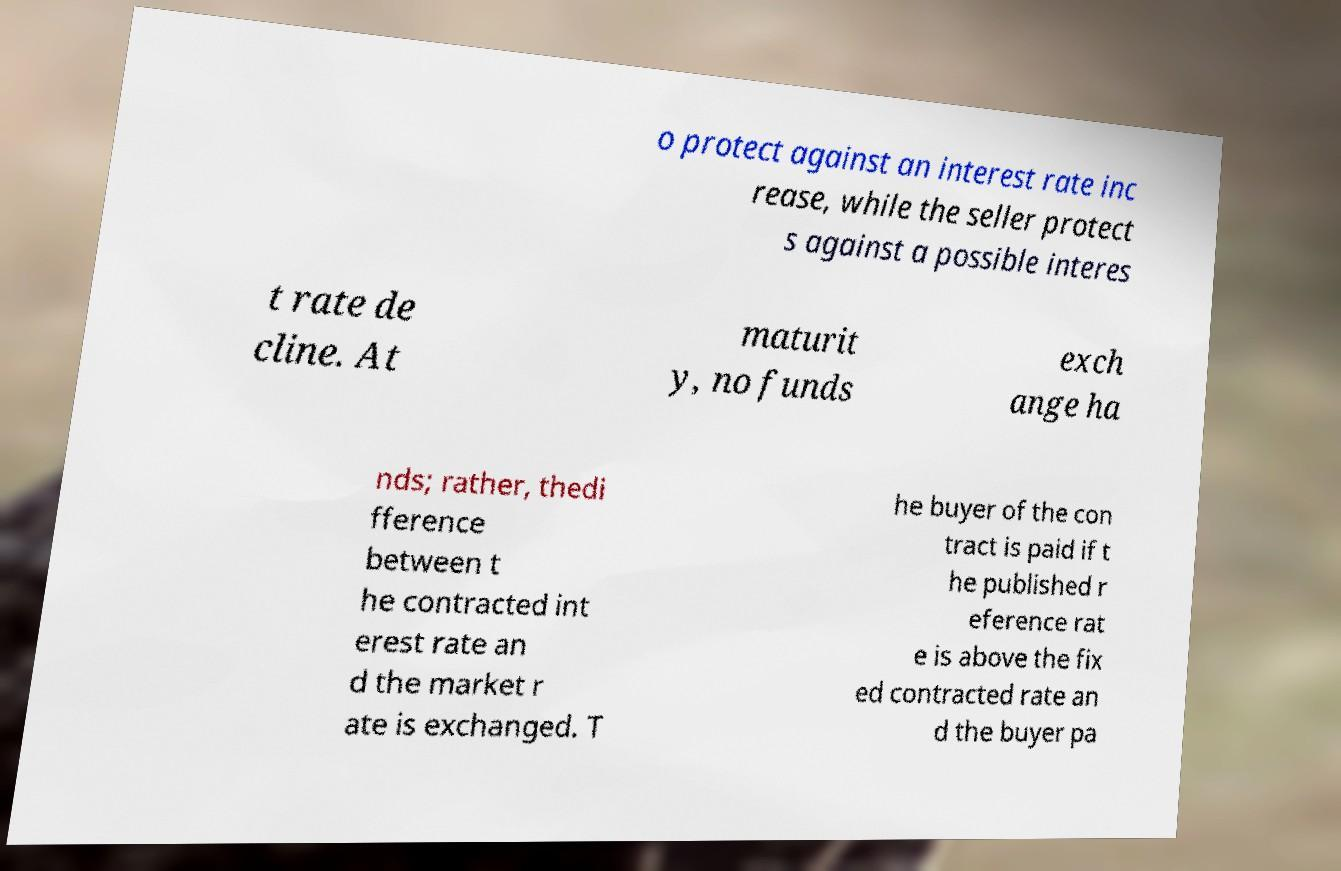Please read and relay the text visible in this image. What does it say? o protect against an interest rate inc rease, while the seller protect s against a possible interes t rate de cline. At maturit y, no funds exch ange ha nds; rather, thedi fference between t he contracted int erest rate an d the market r ate is exchanged. T he buyer of the con tract is paid if t he published r eference rat e is above the fix ed contracted rate an d the buyer pa 